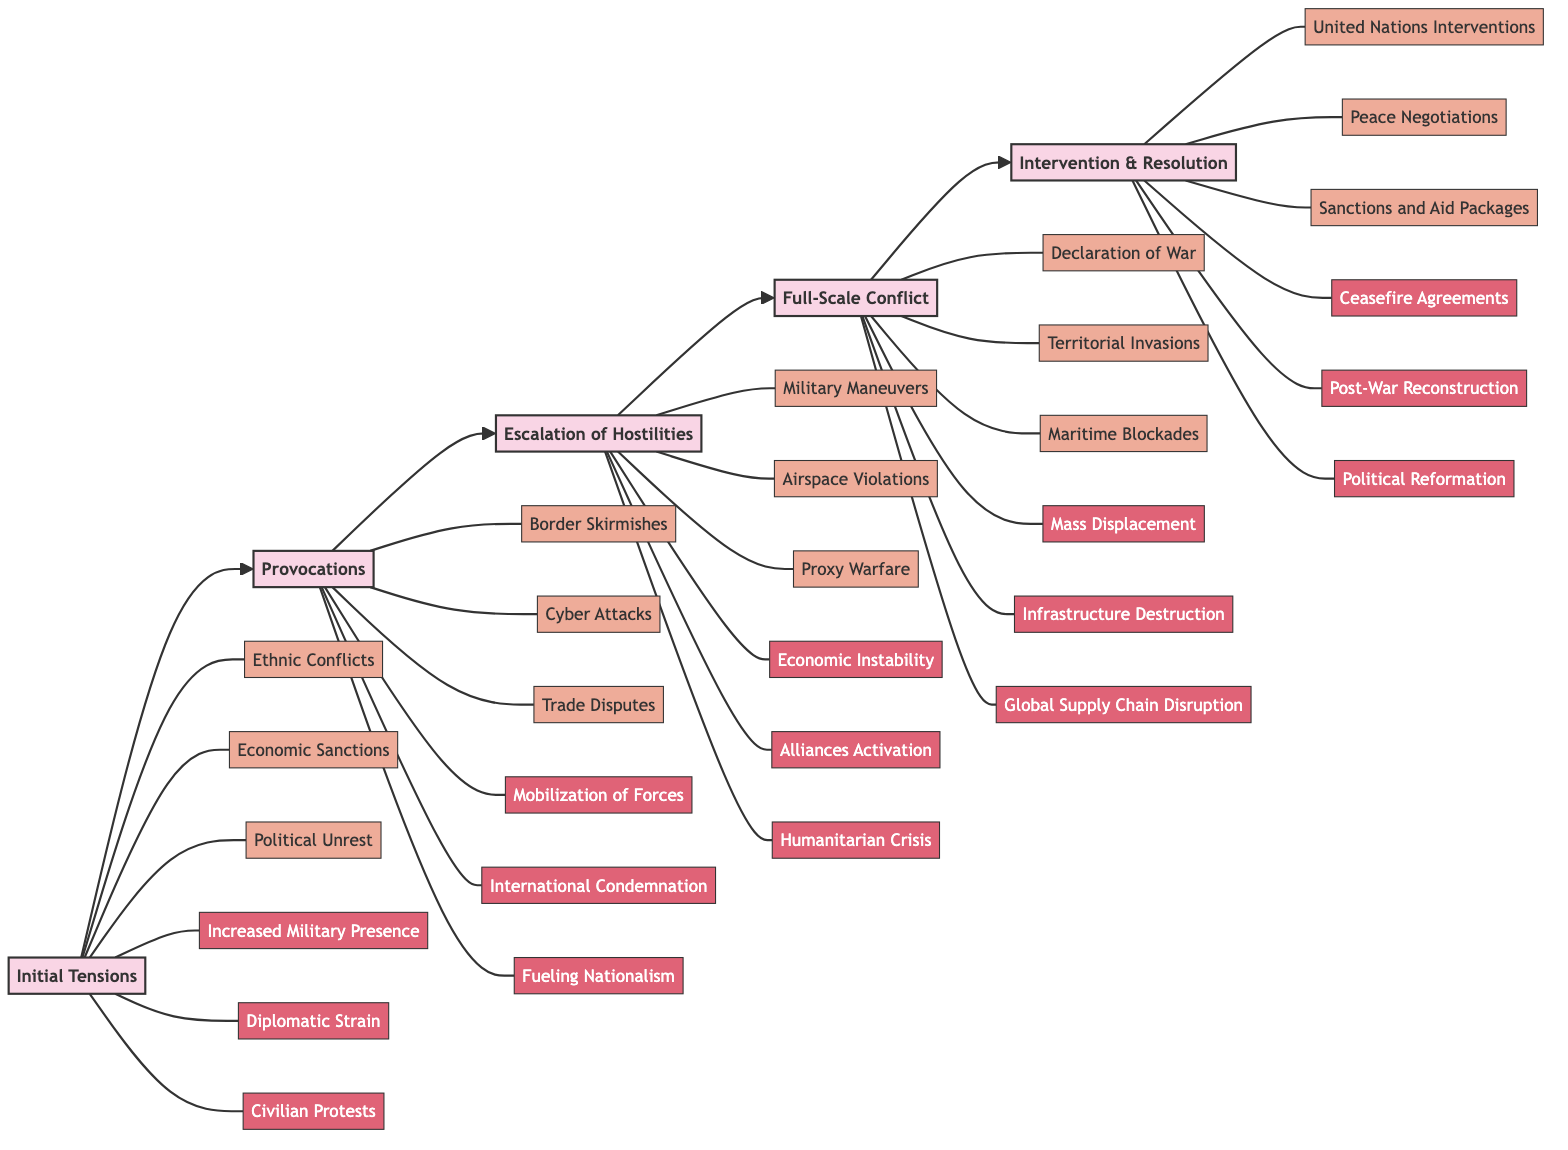What is the first stage of military conflict escalation? The diagram shows "Initial Tensions" as the first stage. This is the starting point of the flowchart that outlines the stages of military conflict escalation.
Answer: Initial Tensions How many factors are listed under "Escalation of Hostilities"? In the flowchart, there are three factors listed under the stage "Escalation of Hostilities": Military Maneuvers, Airspace Violations, and Proxy Warfare.
Answer: 3 What consequence is associated with "Full-Scale Conflict"? The consequence listed under the stage "Full-Scale Conflict" includes Mass Displacement, Infrastructure Destruction, and Global Supply Chain Disruption. Specifically, one of the consequences is "Mass Displacement".
Answer: Mass Displacement Which stage follows "Provocations"? The diagram shows that "Escalation of Hostilities" follows directly after "Provocations". This indicates the progression from provocations to increased hostilities.
Answer: Escalation of Hostilities What factors contribute to "Initial Tensions"? According to the diagram, the factors contributing to "Initial Tensions" include Ethnic Conflicts, Economic Sanctions, and Political Unrest. These are clearly listed under that stage.
Answer: Ethnic Conflicts, Economic Sanctions, Political Unrest Which stage has "Ceasefire Agreements" as a consequence? In the flowchart, "Ceasefire Agreements" is a consequence of the final stage called "Intervention & Resolution". This reflects outcomes related to intervention efforts.
Answer: Intervention & Resolution What is the relationship between "Mobilization of Forces" and "Provocations"? "Mobilization of Forces" is a consequence that arises directly from the stage "Provocations". This indicates that as provocations occur, forces become mobilized in response.
Answer: Consequence of Provocations What are the consequences of the "Escalation of Hostilities" stage? The diagram outlines three consequences of the "Escalation of Hostilities": Economic Instability, Alliances Activation, and Humanitarian Crisis. Each represents potential outcomes of hostilities escalating.
Answer: Economic Instability, Alliances Activation, Humanitarian Crisis How many total stages are represented in the flowchart? The flowchart contains five stages that represent the progression of military conflict escalation from initial tensions to resolution.
Answer: 5 